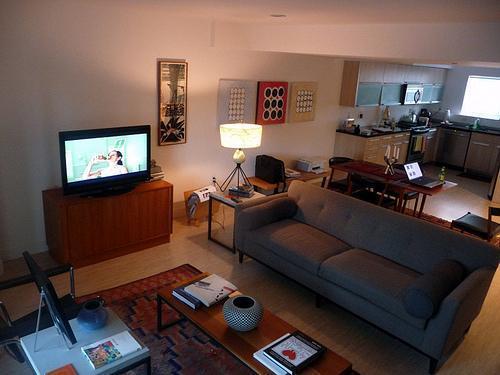How many books are on the coffee table?
Give a very brief answer. 4. 